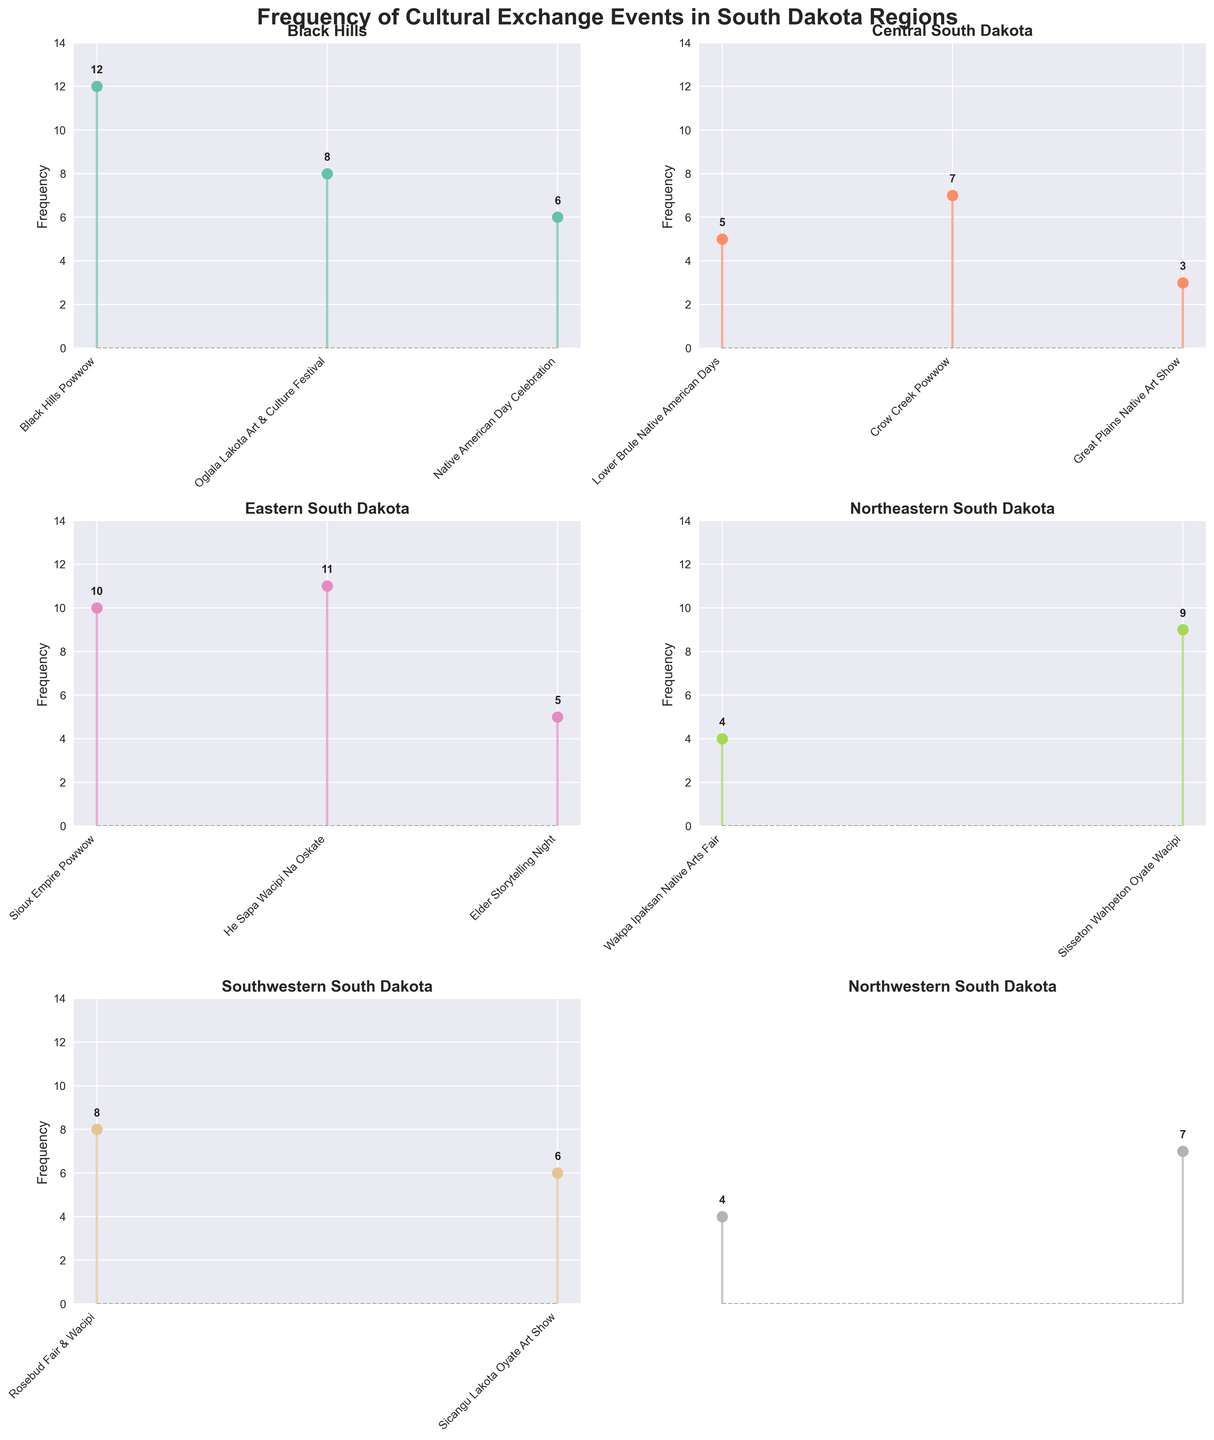Which region has the highest frequency of a single cultural event? The Black Hills region has the highest single event frequency with 12 for Black Hills Powwow.
Answer: Black Hills Which cultural event in Eastern South Dakota has the highest frequency? In the Eastern South Dakota region, the He Sapa Wacipi Na Oskate event has the highest frequency with 11.
Answer: He Sapa Wacipi Na Oskate What's the total frequency of events held in Central South Dakota? Sum the frequencies of Lower Brule Native American Days, Crow Creek Powwow, and Great Plains Native Art Show: 5 + 7 + 3 = 15.
Answer: 15 Which region has the least number of cultural events? The Northeastern South Dakota region hosts the least number of events with only 2 events: Wakpa Ipaksan Native Arts Fair and Sisseton Wahpeton Oyate Wacipi.
Answer: Northeastern South Dakota Compare the total frequencies of events between Black Hills and Southwestern South Dakota. Which has more? Sum the frequencies for each region: Black Hills: 12 + 8 + 6 = 26; Southwestern South Dakota: 8 + 6 = 14. Black Hills has more events.
Answer: Black Hills What is the average frequency of events in Northwestern South Dakota? Calculate the average of the frequencies of Standing Rock Cultural Day and Tribal Harvest Festival: (4 + 7) / 2 = 5.5.
Answer: 5.5 Which event has the second highest frequency in the Black Hills region? In Black Hills, the event with the second highest frequency is Oglala Lakota Art & Culture Festival with a frequency of 8.
Answer: Oglala Lakota Art & Culture Festival What is the frequency difference between the highest and lowest frequency events in the Northeastern South Dakota region? In Northeastern South Dakota, the frequencies are 4 and 9. The difference is 9 - 4 = 5.
Answer: 5 If you combine the frequencies of events from Eastern South Dakota and Southeastern South Dakota, what's the total? Sum the frequencies of events: Eastern South Dakota: 10 + 11 + 5 = 26.
Answer: 26 Which events have a frequency equal to 6? The events with a frequency of 6 are Native American Day Celebration and Sicangu Lakota Oyate Art Show.
Answer: Native American Day Celebration, Sicangu Lakota Oyate Art Show 